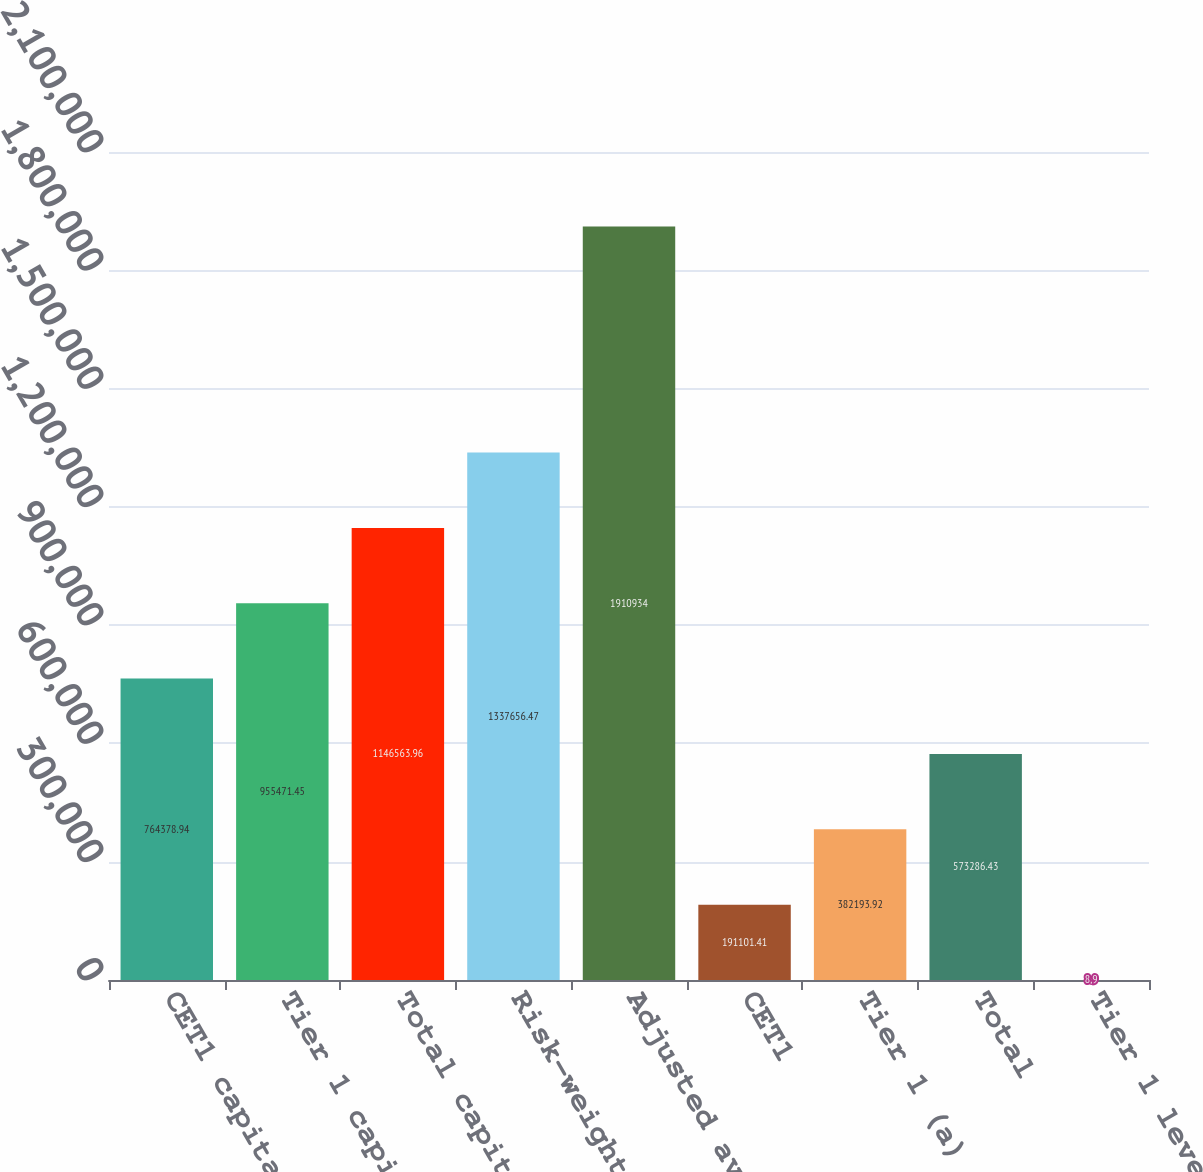Convert chart to OTSL. <chart><loc_0><loc_0><loc_500><loc_500><bar_chart><fcel>CET1 capital<fcel>Tier 1 capital (a)<fcel>Total capital<fcel>Risk-weighted<fcel>Adjusted average (b)<fcel>CET1<fcel>Tier 1 (a)<fcel>Total<fcel>Tier 1 leverage (d)<nl><fcel>764379<fcel>955471<fcel>1.14656e+06<fcel>1.33766e+06<fcel>1.91093e+06<fcel>191101<fcel>382194<fcel>573286<fcel>8.9<nl></chart> 